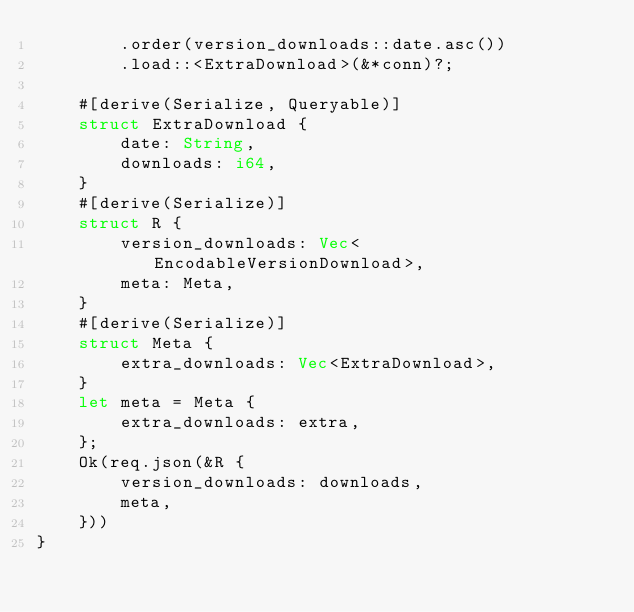<code> <loc_0><loc_0><loc_500><loc_500><_Rust_>        .order(version_downloads::date.asc())
        .load::<ExtraDownload>(&*conn)?;

    #[derive(Serialize, Queryable)]
    struct ExtraDownload {
        date: String,
        downloads: i64,
    }
    #[derive(Serialize)]
    struct R {
        version_downloads: Vec<EncodableVersionDownload>,
        meta: Meta,
    }
    #[derive(Serialize)]
    struct Meta {
        extra_downloads: Vec<ExtraDownload>,
    }
    let meta = Meta {
        extra_downloads: extra,
    };
    Ok(req.json(&R {
        version_downloads: downloads,
        meta,
    }))
}
</code> 